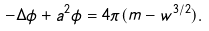<formula> <loc_0><loc_0><loc_500><loc_500>- \Delta \phi + a ^ { 2 } \phi = 4 \pi ( m - w ^ { 3 / 2 } ) .</formula> 